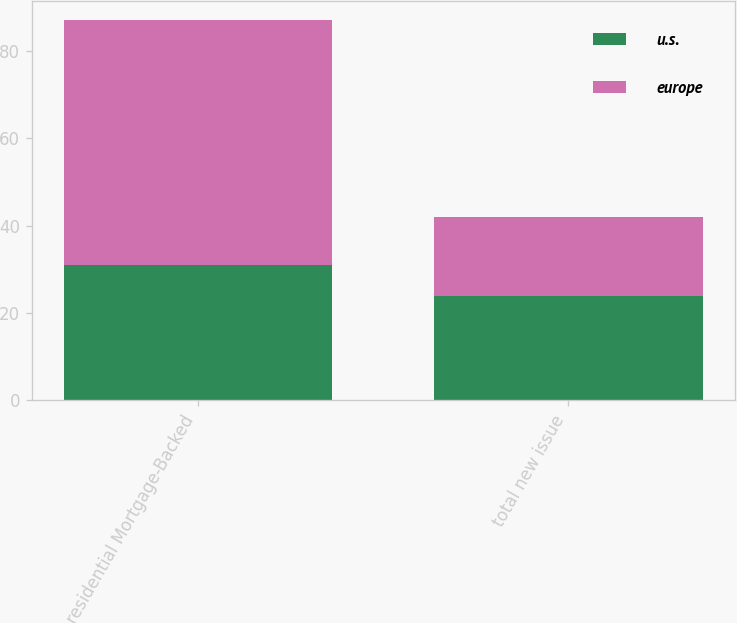Convert chart to OTSL. <chart><loc_0><loc_0><loc_500><loc_500><stacked_bar_chart><ecel><fcel>residential Mortgage-Backed<fcel>total new issue<nl><fcel>u.s.<fcel>31<fcel>24<nl><fcel>europe<fcel>56<fcel>18<nl></chart> 